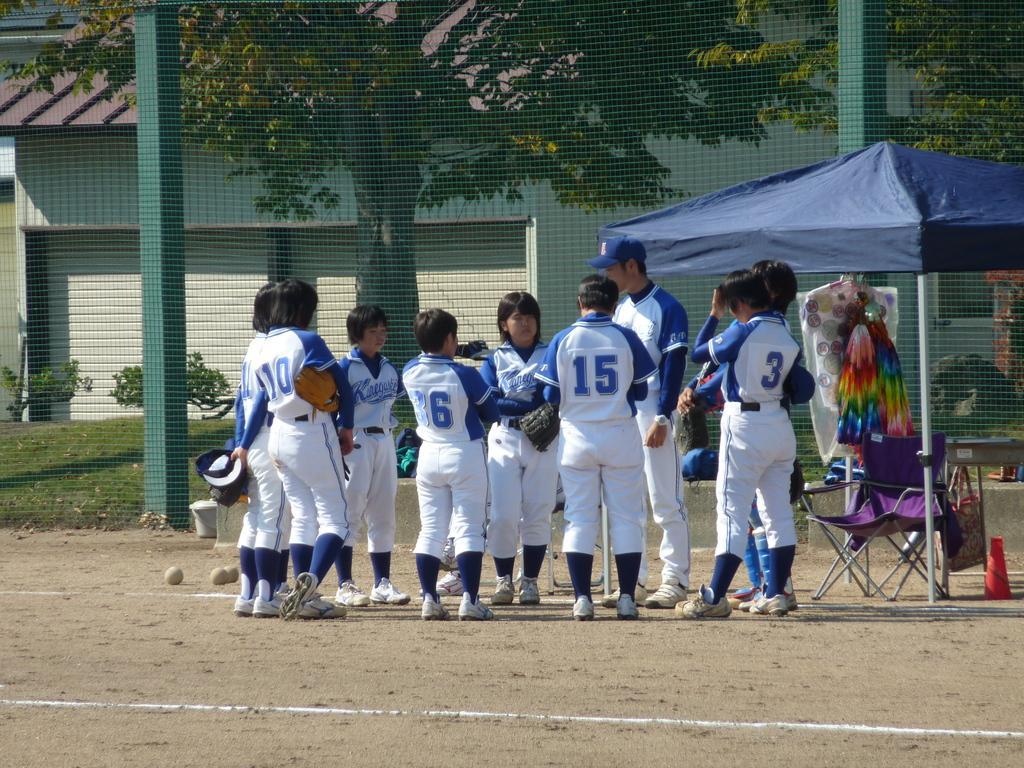Describe this image in one or two sentences. In this image, there are a few people. We can see a tent, a chair and some objects. We can see a house and some poles. We can see the net and the ground with some objects. We can see some grass, plants and trees. 